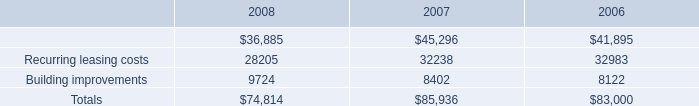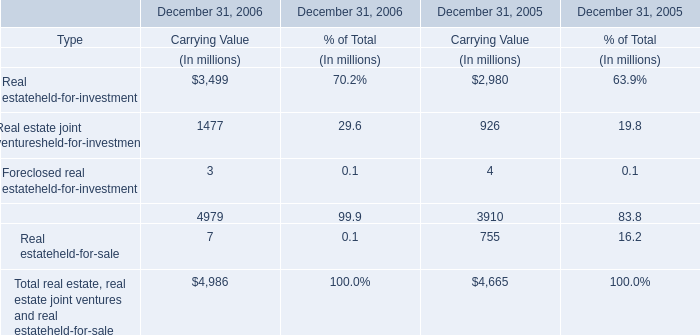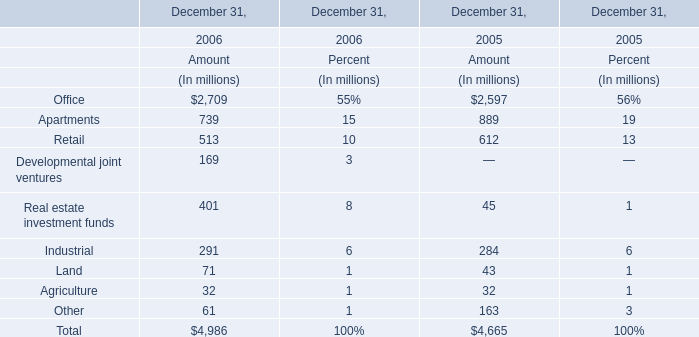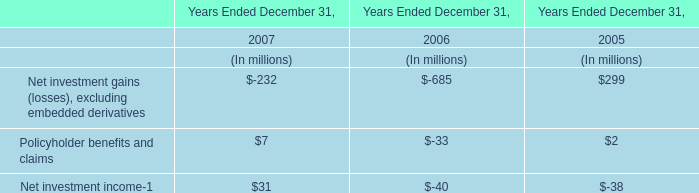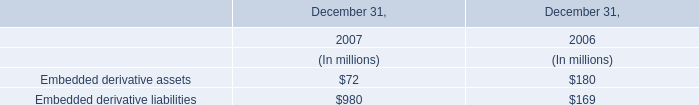What is the growing rate of Apartments in the year with the most Office? 
Computations: ((739 - 889) / 739)
Answer: -0.20298. 